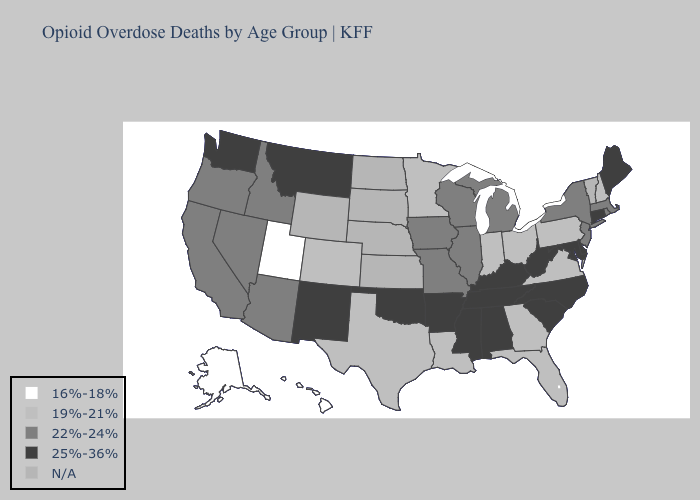Name the states that have a value in the range 25%-36%?
Concise answer only. Alabama, Arkansas, Connecticut, Delaware, Kentucky, Maine, Maryland, Mississippi, Montana, New Mexico, North Carolina, Oklahoma, South Carolina, Tennessee, Washington, West Virginia. Does Iowa have the lowest value in the MidWest?
Be succinct. No. Which states have the lowest value in the Northeast?
Write a very short answer. New Hampshire, Pennsylvania. What is the lowest value in the USA?
Concise answer only. 16%-18%. Among the states that border Pennsylvania , does New York have the highest value?
Write a very short answer. No. Does Hawaii have the lowest value in the USA?
Be succinct. Yes. What is the highest value in states that border Nevada?
Concise answer only. 22%-24%. What is the highest value in the Northeast ?
Keep it brief. 25%-36%. Which states have the highest value in the USA?
Write a very short answer. Alabama, Arkansas, Connecticut, Delaware, Kentucky, Maine, Maryland, Mississippi, Montana, New Mexico, North Carolina, Oklahoma, South Carolina, Tennessee, Washington, West Virginia. What is the value of South Carolina?
Quick response, please. 25%-36%. What is the value of Kentucky?
Concise answer only. 25%-36%. What is the highest value in the MidWest ?
Write a very short answer. 22%-24%. Among the states that border Texas , which have the highest value?
Concise answer only. Arkansas, New Mexico, Oklahoma. What is the lowest value in states that border Oklahoma?
Concise answer only. 19%-21%. 